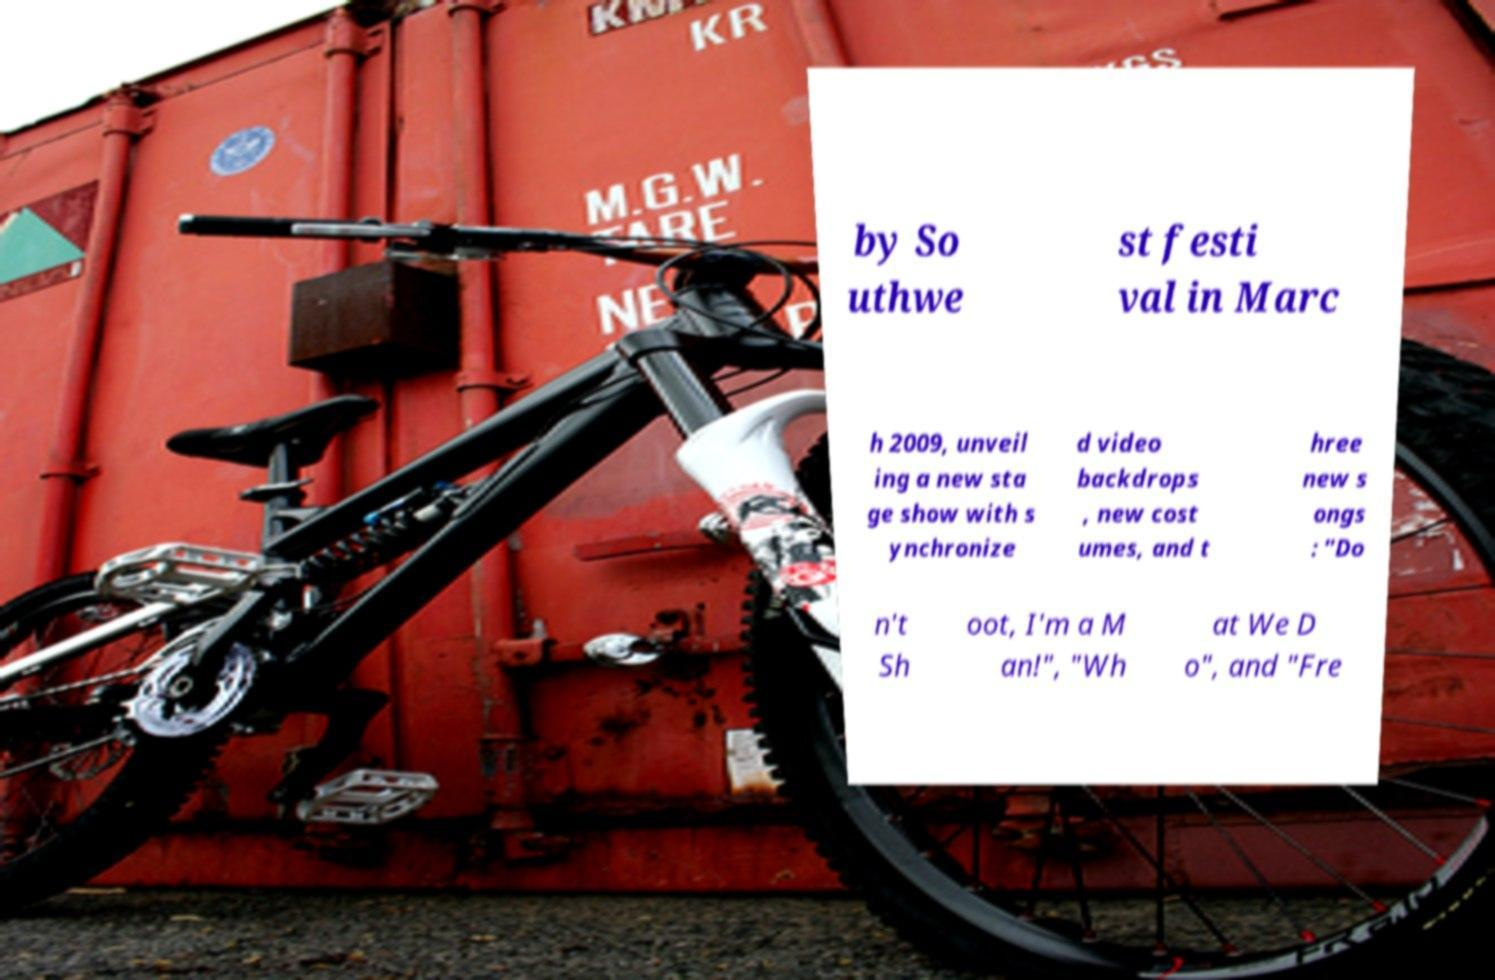Could you extract and type out the text from this image? by So uthwe st festi val in Marc h 2009, unveil ing a new sta ge show with s ynchronize d video backdrops , new cost umes, and t hree new s ongs : "Do n't Sh oot, I'm a M an!", "Wh at We D o", and "Fre 